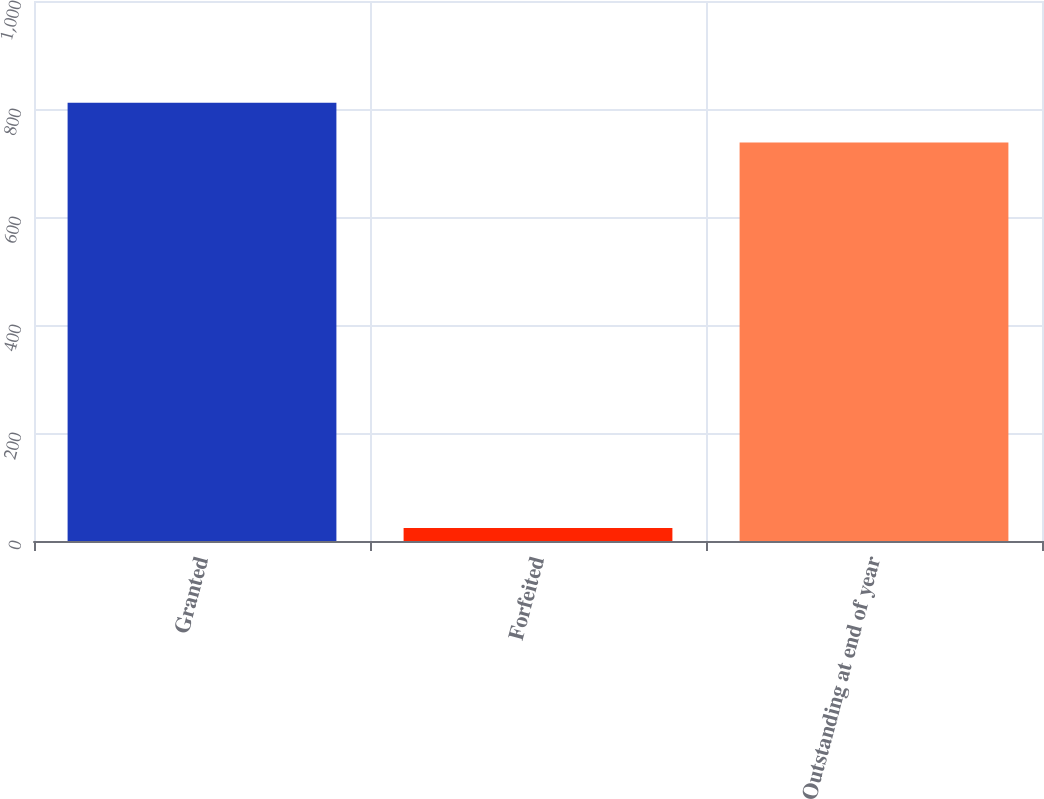Convert chart to OTSL. <chart><loc_0><loc_0><loc_500><loc_500><bar_chart><fcel>Granted<fcel>Forfeited<fcel>Outstanding at end of year<nl><fcel>811.8<fcel>24<fcel>738<nl></chart> 